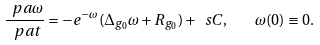<formula> <loc_0><loc_0><loc_500><loc_500>\frac { \ p a \omega } { \ p a t } = - e ^ { - \omega } ( \Delta _ { g _ { 0 } } \omega + R _ { g _ { 0 } } ) + \ s C , \quad \omega ( 0 ) \equiv 0 .</formula> 